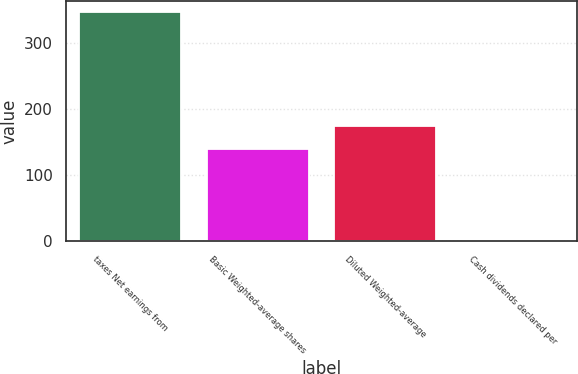Convert chart. <chart><loc_0><loc_0><loc_500><loc_500><bar_chart><fcel>taxes Net earnings from<fcel>Basic Weighted-average shares<fcel>Diluted Weighted-average<fcel>Cash dividends declared per<nl><fcel>346<fcel>140<fcel>174.57<fcel>0.28<nl></chart> 